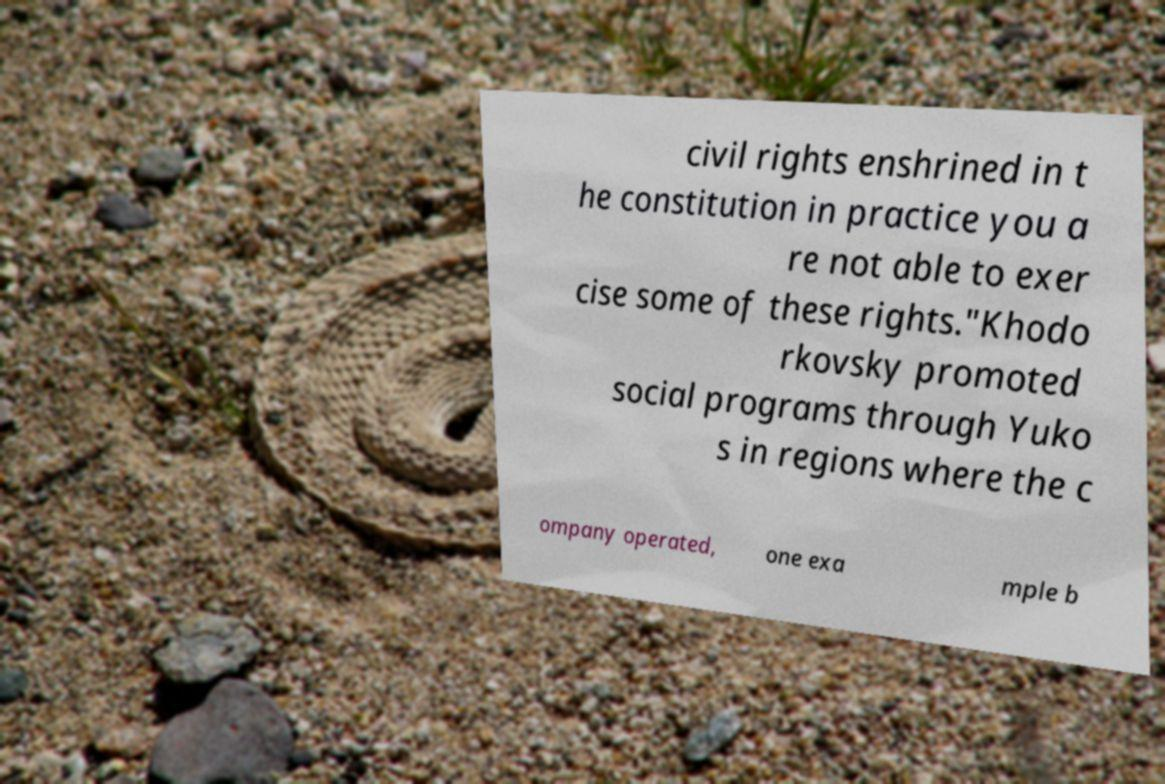Can you read and provide the text displayed in the image?This photo seems to have some interesting text. Can you extract and type it out for me? civil rights enshrined in t he constitution in practice you a re not able to exer cise some of these rights."Khodo rkovsky promoted social programs through Yuko s in regions where the c ompany operated, one exa mple b 